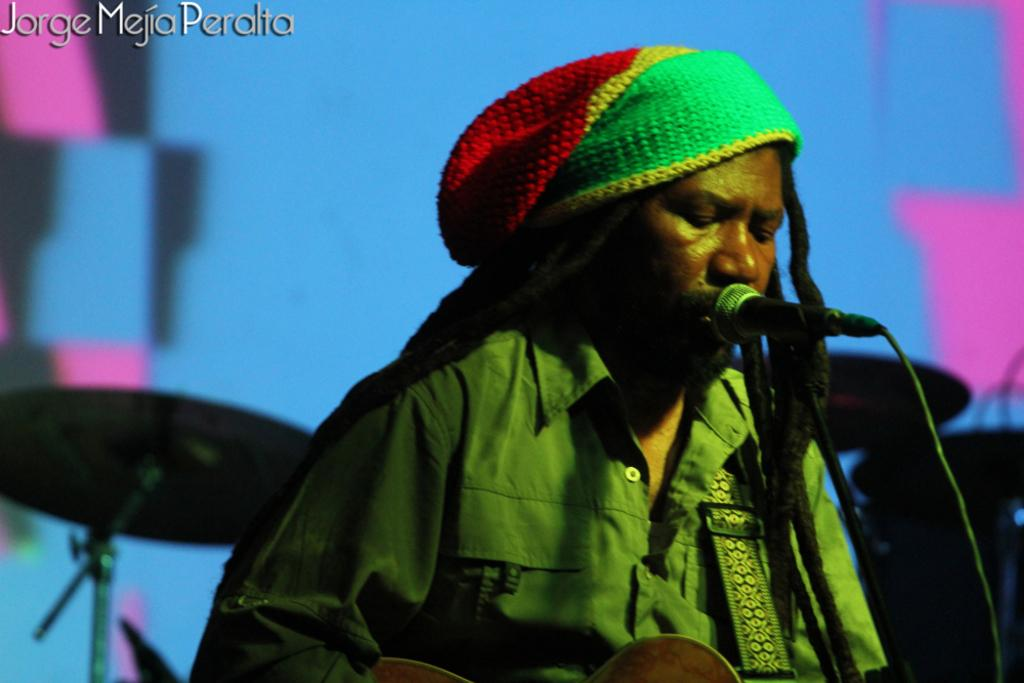What is the person in the image doing? The person is standing in front of a mic. What can be seen in the background of the image? There are musical instruments in the background. Is there any text visible in the image? Yes, there is some text in the top right-hand corner of the image. What type of cable is being used to connect the oatmeal to the mic? There is no oatmeal present in the image, and therefore no cable connecting it to the mic. 